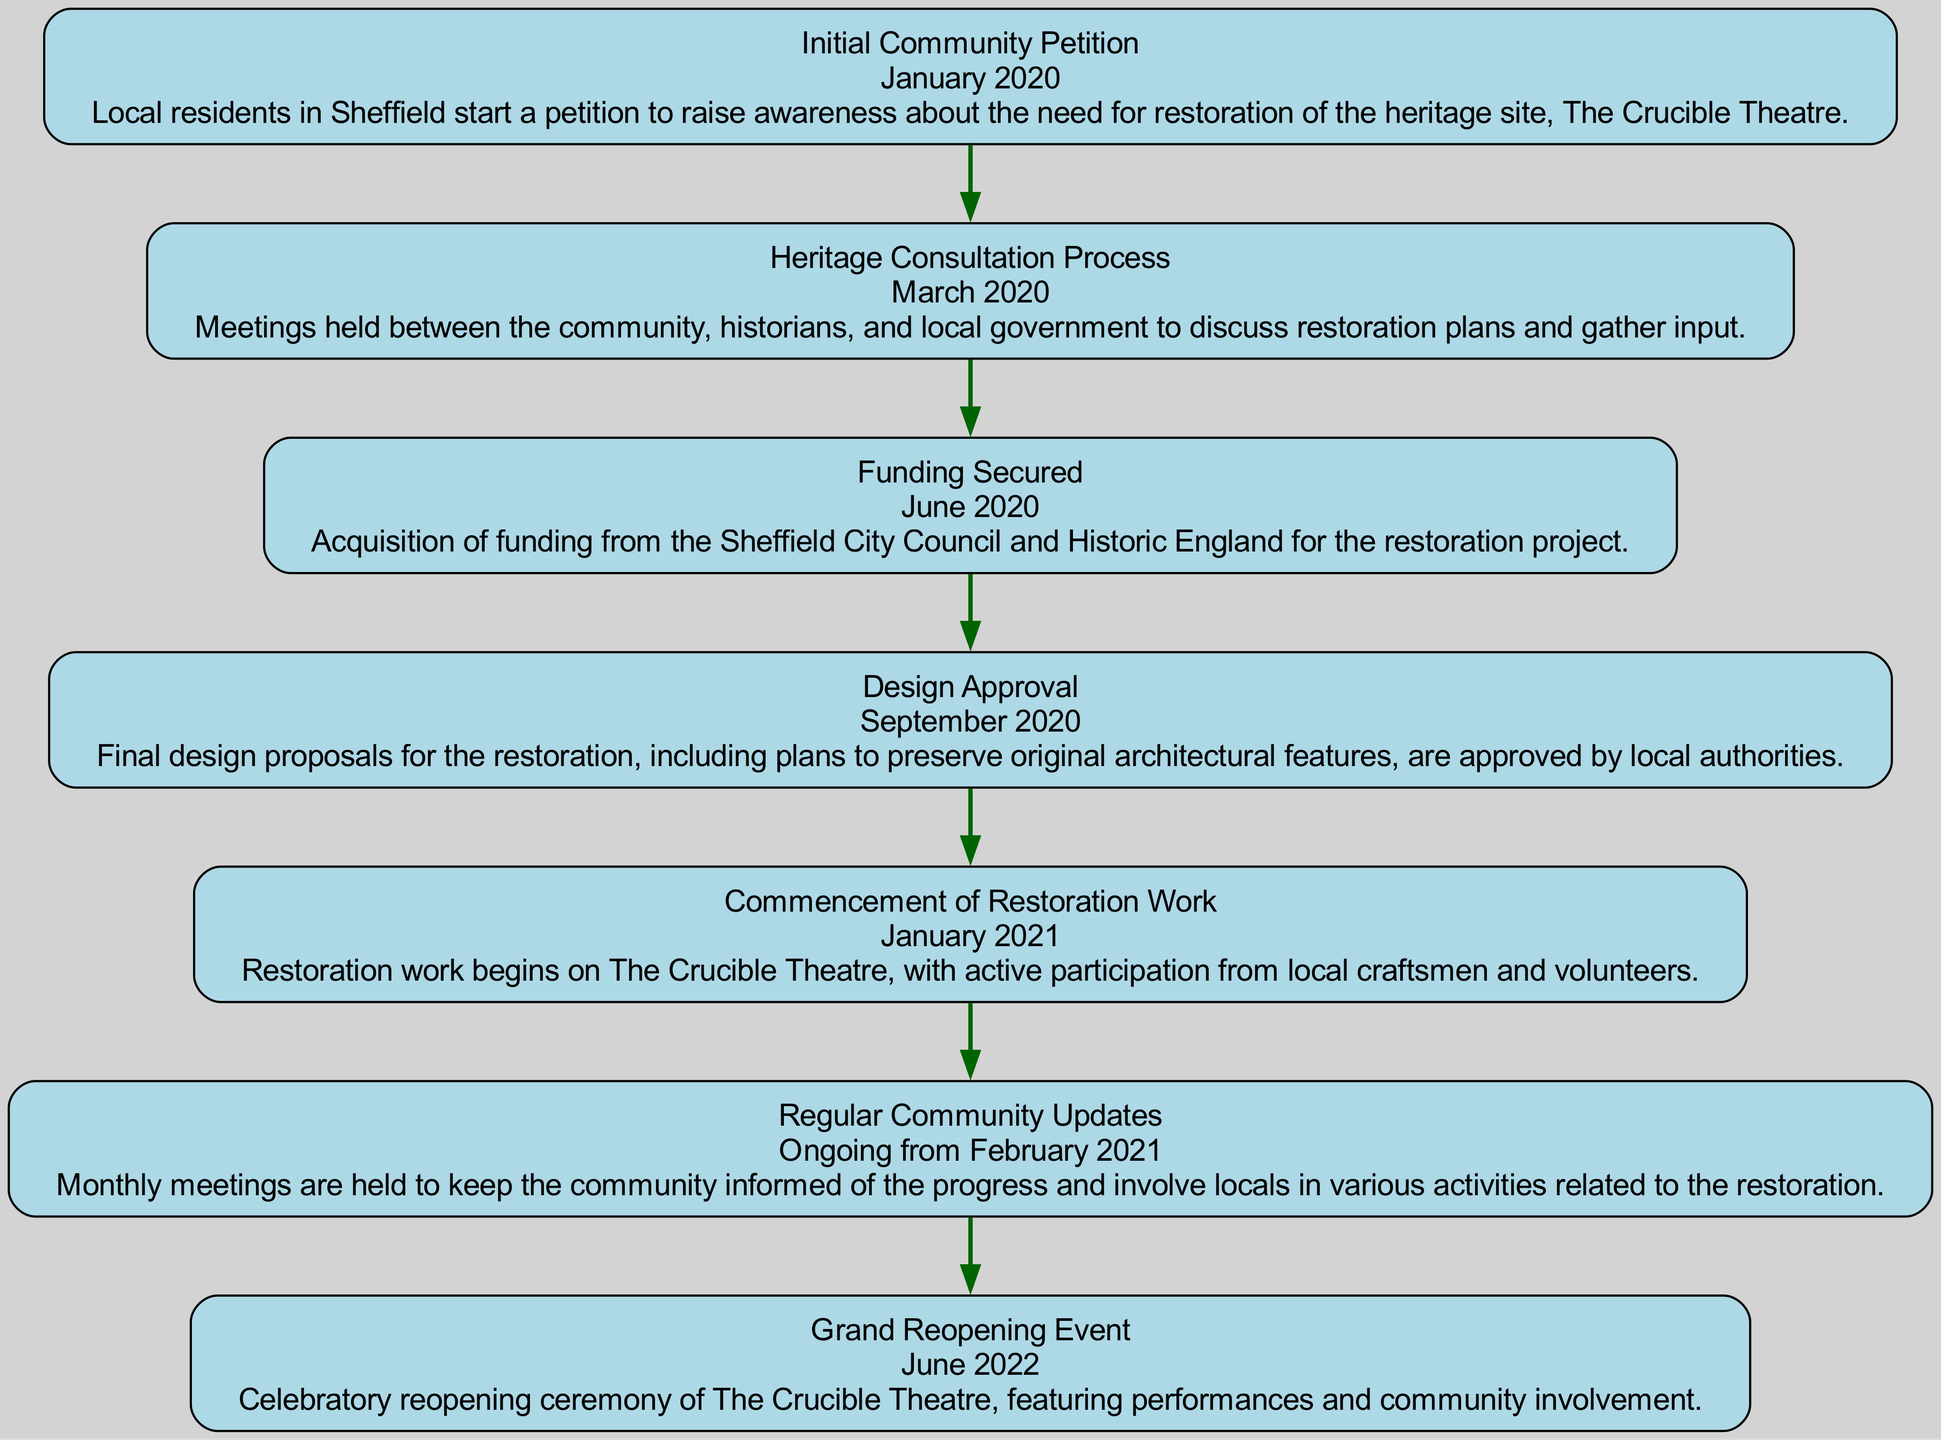What is the first event in the restoration process? The first event is identified by looking at the beginning of the flow chart, which is labeled as "Initial Community Petition" with its corresponding date.
Answer: Initial Community Petition How many nodes are there in total? Counting all the elements listed in the flow chart from the initial community petition to the grand reopening event gives the total number of nodes. There are seven distinct nodes.
Answer: 7 What date did the restoration work begin? The date for the "Commencement of Restoration Work" is found by locating the specific node in the chart that indicates when the actual restoration started. The date is January 2021.
Answer: January 2021 Which entity provided funding for the restoration? By examining the "Funding Secured" node, we can identify Sheffield City Council and Historic England as the funders.
Answer: Sheffield City Council and Historic England What event followed the "Design Approval"? Following the "Design Approval" node, we look for the subsequent node labeled "Commencement of Restoration Work." This indicates the progression after the design was approved.
Answer: Commencement of Restoration Work What ongoing activity started in February 2021? The diagram indicates that "Regular Community Updates" began in February 2021 and continue on an ongoing basis. This shows how community engagement was maintained.
Answer: Regular Community Updates What milestone marks the conclusion of this flow chart? The final event listed in the flow chart is the "Grand Reopening Event," which signifies the culmination of the restoration project.
Answer: Grand Reopening Event What is the relationship between the funding acquisition and design approval? The flow chart presents a sequence where the "Funding Secured" event precedes the "Design Approval," indicating that funding was required before the design could be assessed and approved.
Answer: Funding Secured precedes Design Approval 